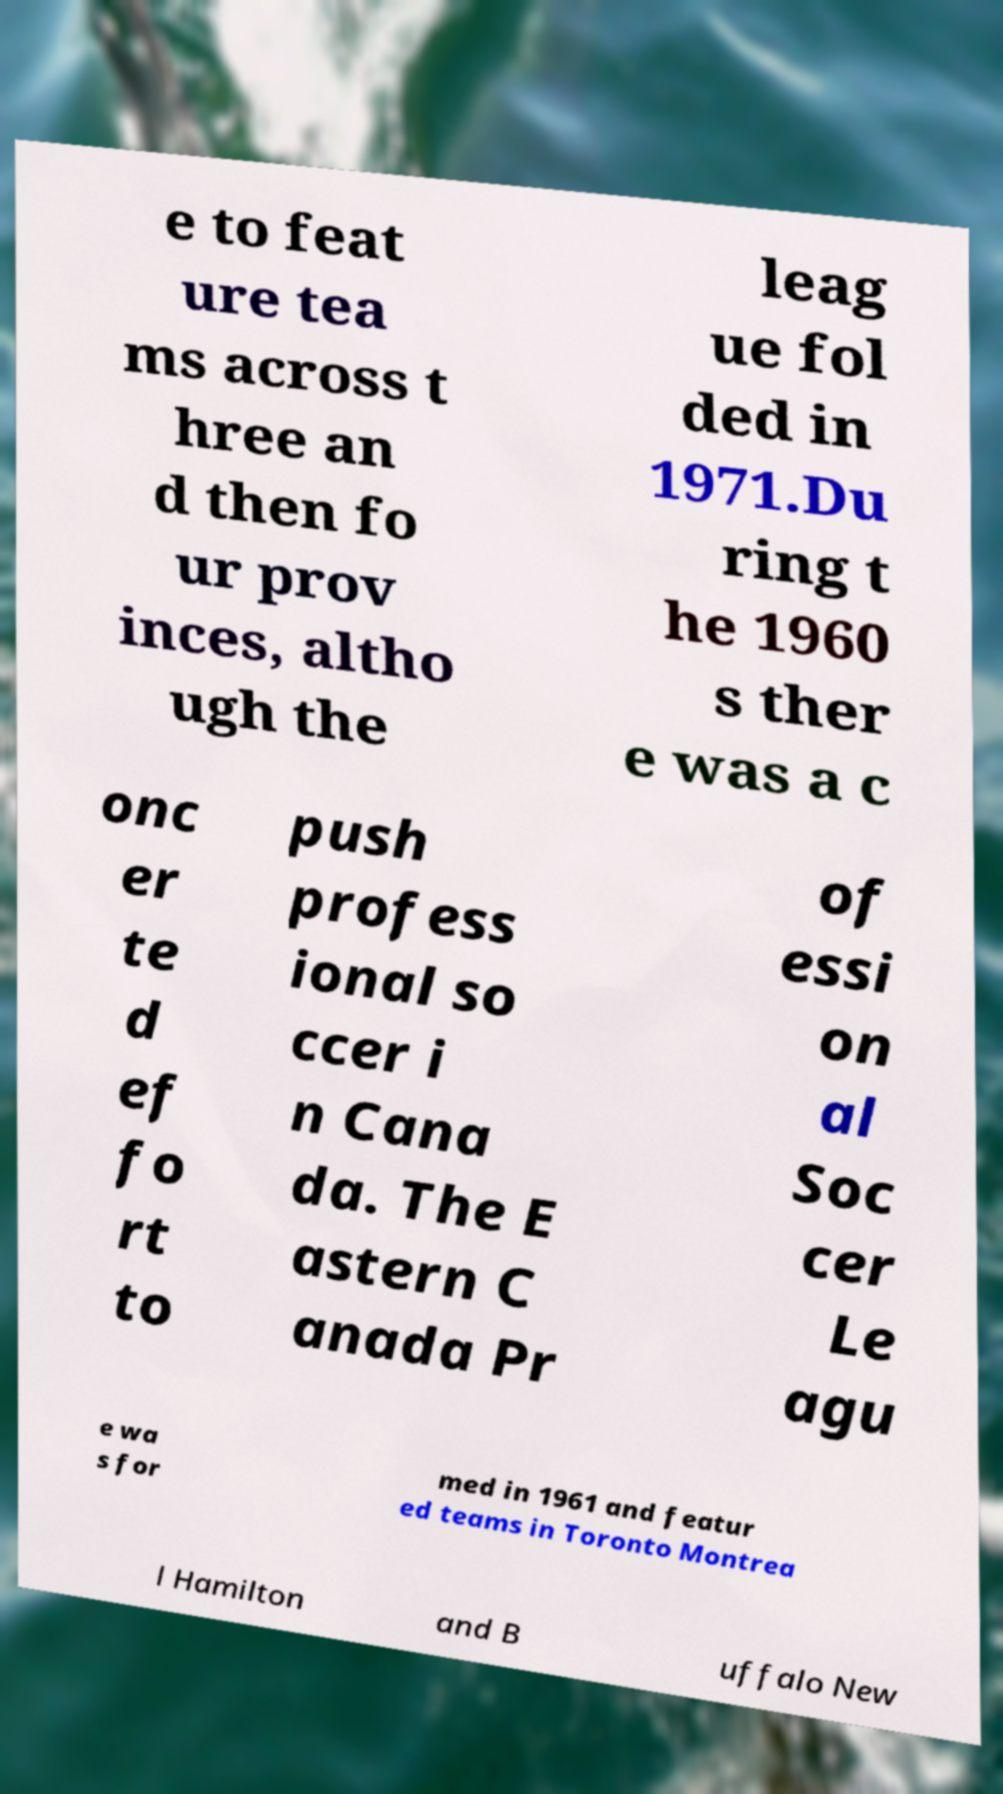Could you extract and type out the text from this image? e to feat ure tea ms across t hree an d then fo ur prov inces, altho ugh the leag ue fol ded in 1971.Du ring t he 1960 s ther e was a c onc er te d ef fo rt to push profess ional so ccer i n Cana da. The E astern C anada Pr of essi on al Soc cer Le agu e wa s for med in 1961 and featur ed teams in Toronto Montrea l Hamilton and B uffalo New 